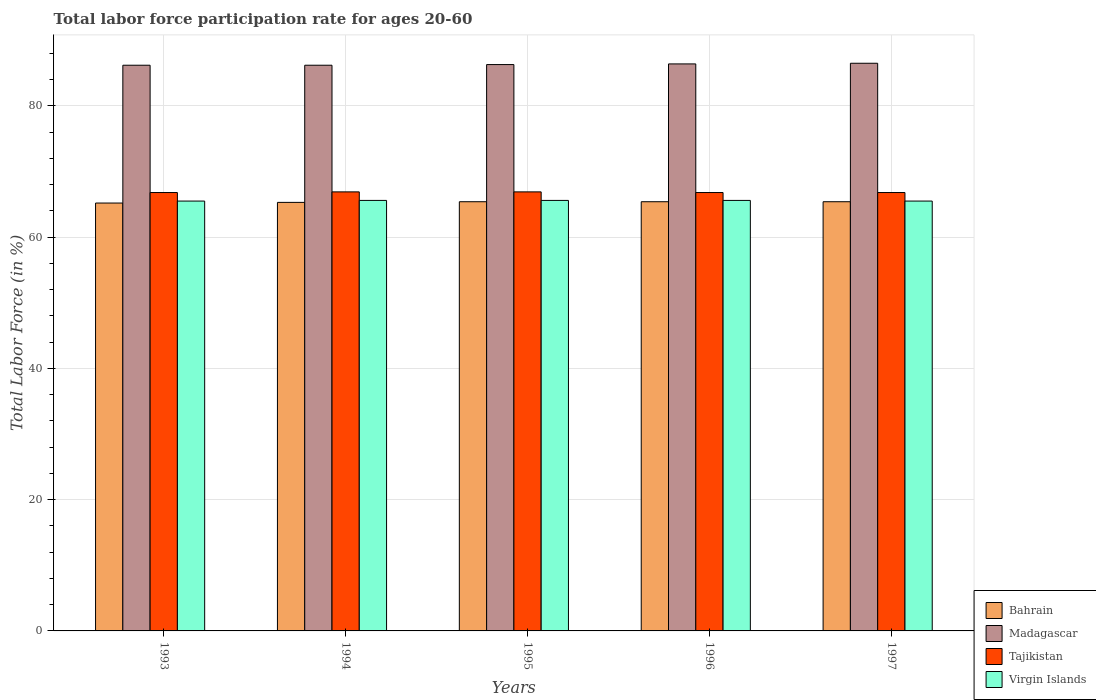Are the number of bars per tick equal to the number of legend labels?
Ensure brevity in your answer.  Yes. Are the number of bars on each tick of the X-axis equal?
Ensure brevity in your answer.  Yes. What is the label of the 3rd group of bars from the left?
Your answer should be very brief. 1995. In how many cases, is the number of bars for a given year not equal to the number of legend labels?
Your response must be concise. 0. What is the labor force participation rate in Virgin Islands in 1995?
Give a very brief answer. 65.6. Across all years, what is the maximum labor force participation rate in Tajikistan?
Your answer should be very brief. 66.9. Across all years, what is the minimum labor force participation rate in Tajikistan?
Offer a terse response. 66.8. In which year was the labor force participation rate in Bahrain maximum?
Your answer should be very brief. 1995. What is the total labor force participation rate in Bahrain in the graph?
Your answer should be very brief. 326.7. What is the difference between the labor force participation rate in Tajikistan in 1996 and that in 1997?
Your response must be concise. 0. What is the difference between the labor force participation rate in Virgin Islands in 1997 and the labor force participation rate in Madagascar in 1995?
Keep it short and to the point. -20.8. What is the average labor force participation rate in Tajikistan per year?
Provide a succinct answer. 66.84. In the year 1993, what is the difference between the labor force participation rate in Tajikistan and labor force participation rate in Virgin Islands?
Offer a very short reply. 1.3. What is the ratio of the labor force participation rate in Madagascar in 1994 to that in 1997?
Provide a succinct answer. 1. Is the labor force participation rate in Tajikistan in 1993 less than that in 1994?
Keep it short and to the point. Yes. Is the difference between the labor force participation rate in Tajikistan in 1995 and 1996 greater than the difference between the labor force participation rate in Virgin Islands in 1995 and 1996?
Ensure brevity in your answer.  Yes. What is the difference between the highest and the second highest labor force participation rate in Virgin Islands?
Ensure brevity in your answer.  0. What is the difference between the highest and the lowest labor force participation rate in Virgin Islands?
Provide a short and direct response. 0.1. In how many years, is the labor force participation rate in Virgin Islands greater than the average labor force participation rate in Virgin Islands taken over all years?
Your answer should be very brief. 3. Is the sum of the labor force participation rate in Madagascar in 1994 and 1995 greater than the maximum labor force participation rate in Bahrain across all years?
Your answer should be very brief. Yes. Is it the case that in every year, the sum of the labor force participation rate in Madagascar and labor force participation rate in Tajikistan is greater than the sum of labor force participation rate in Virgin Islands and labor force participation rate in Bahrain?
Give a very brief answer. Yes. What does the 2nd bar from the left in 1995 represents?
Ensure brevity in your answer.  Madagascar. What does the 3rd bar from the right in 1994 represents?
Give a very brief answer. Madagascar. Are all the bars in the graph horizontal?
Offer a very short reply. No. What is the difference between two consecutive major ticks on the Y-axis?
Your response must be concise. 20. Are the values on the major ticks of Y-axis written in scientific E-notation?
Offer a terse response. No. Does the graph contain grids?
Your response must be concise. Yes. How many legend labels are there?
Offer a terse response. 4. What is the title of the graph?
Provide a short and direct response. Total labor force participation rate for ages 20-60. What is the Total Labor Force (in %) in Bahrain in 1993?
Make the answer very short. 65.2. What is the Total Labor Force (in %) of Madagascar in 1993?
Offer a terse response. 86.2. What is the Total Labor Force (in %) of Tajikistan in 1993?
Offer a terse response. 66.8. What is the Total Labor Force (in %) of Virgin Islands in 1993?
Provide a succinct answer. 65.5. What is the Total Labor Force (in %) in Bahrain in 1994?
Your answer should be very brief. 65.3. What is the Total Labor Force (in %) in Madagascar in 1994?
Offer a very short reply. 86.2. What is the Total Labor Force (in %) in Tajikistan in 1994?
Give a very brief answer. 66.9. What is the Total Labor Force (in %) in Virgin Islands in 1994?
Your response must be concise. 65.6. What is the Total Labor Force (in %) in Bahrain in 1995?
Give a very brief answer. 65.4. What is the Total Labor Force (in %) of Madagascar in 1995?
Give a very brief answer. 86.3. What is the Total Labor Force (in %) in Tajikistan in 1995?
Ensure brevity in your answer.  66.9. What is the Total Labor Force (in %) of Virgin Islands in 1995?
Your response must be concise. 65.6. What is the Total Labor Force (in %) in Bahrain in 1996?
Provide a short and direct response. 65.4. What is the Total Labor Force (in %) in Madagascar in 1996?
Keep it short and to the point. 86.4. What is the Total Labor Force (in %) in Tajikistan in 1996?
Keep it short and to the point. 66.8. What is the Total Labor Force (in %) of Virgin Islands in 1996?
Make the answer very short. 65.6. What is the Total Labor Force (in %) in Bahrain in 1997?
Offer a terse response. 65.4. What is the Total Labor Force (in %) in Madagascar in 1997?
Make the answer very short. 86.5. What is the Total Labor Force (in %) of Tajikistan in 1997?
Provide a succinct answer. 66.8. What is the Total Labor Force (in %) in Virgin Islands in 1997?
Your answer should be compact. 65.5. Across all years, what is the maximum Total Labor Force (in %) of Bahrain?
Offer a very short reply. 65.4. Across all years, what is the maximum Total Labor Force (in %) in Madagascar?
Provide a short and direct response. 86.5. Across all years, what is the maximum Total Labor Force (in %) of Tajikistan?
Provide a succinct answer. 66.9. Across all years, what is the maximum Total Labor Force (in %) in Virgin Islands?
Provide a short and direct response. 65.6. Across all years, what is the minimum Total Labor Force (in %) in Bahrain?
Provide a short and direct response. 65.2. Across all years, what is the minimum Total Labor Force (in %) in Madagascar?
Your answer should be very brief. 86.2. Across all years, what is the minimum Total Labor Force (in %) in Tajikistan?
Keep it short and to the point. 66.8. Across all years, what is the minimum Total Labor Force (in %) in Virgin Islands?
Provide a succinct answer. 65.5. What is the total Total Labor Force (in %) of Bahrain in the graph?
Offer a terse response. 326.7. What is the total Total Labor Force (in %) of Madagascar in the graph?
Offer a very short reply. 431.6. What is the total Total Labor Force (in %) of Tajikistan in the graph?
Make the answer very short. 334.2. What is the total Total Labor Force (in %) of Virgin Islands in the graph?
Your response must be concise. 327.8. What is the difference between the Total Labor Force (in %) in Bahrain in 1993 and that in 1994?
Provide a short and direct response. -0.1. What is the difference between the Total Labor Force (in %) of Madagascar in 1993 and that in 1994?
Offer a terse response. 0. What is the difference between the Total Labor Force (in %) of Tajikistan in 1993 and that in 1994?
Your response must be concise. -0.1. What is the difference between the Total Labor Force (in %) in Bahrain in 1993 and that in 1995?
Your answer should be compact. -0.2. What is the difference between the Total Labor Force (in %) in Tajikistan in 1993 and that in 1995?
Ensure brevity in your answer.  -0.1. What is the difference between the Total Labor Force (in %) in Virgin Islands in 1993 and that in 1995?
Provide a succinct answer. -0.1. What is the difference between the Total Labor Force (in %) of Bahrain in 1993 and that in 1996?
Give a very brief answer. -0.2. What is the difference between the Total Labor Force (in %) of Virgin Islands in 1993 and that in 1996?
Give a very brief answer. -0.1. What is the difference between the Total Labor Force (in %) in Bahrain in 1993 and that in 1997?
Make the answer very short. -0.2. What is the difference between the Total Labor Force (in %) of Madagascar in 1993 and that in 1997?
Ensure brevity in your answer.  -0.3. What is the difference between the Total Labor Force (in %) in Tajikistan in 1993 and that in 1997?
Keep it short and to the point. 0. What is the difference between the Total Labor Force (in %) in Bahrain in 1994 and that in 1995?
Your answer should be very brief. -0.1. What is the difference between the Total Labor Force (in %) in Tajikistan in 1994 and that in 1995?
Provide a short and direct response. 0. What is the difference between the Total Labor Force (in %) of Virgin Islands in 1994 and that in 1995?
Your answer should be compact. 0. What is the difference between the Total Labor Force (in %) of Madagascar in 1994 and that in 1996?
Offer a very short reply. -0.2. What is the difference between the Total Labor Force (in %) of Bahrain in 1994 and that in 1997?
Offer a terse response. -0.1. What is the difference between the Total Labor Force (in %) in Virgin Islands in 1995 and that in 1996?
Make the answer very short. 0. What is the difference between the Total Labor Force (in %) in Madagascar in 1995 and that in 1997?
Make the answer very short. -0.2. What is the difference between the Total Labor Force (in %) in Tajikistan in 1995 and that in 1997?
Give a very brief answer. 0.1. What is the difference between the Total Labor Force (in %) in Virgin Islands in 1995 and that in 1997?
Your response must be concise. 0.1. What is the difference between the Total Labor Force (in %) of Tajikistan in 1996 and that in 1997?
Your answer should be compact. 0. What is the difference between the Total Labor Force (in %) of Madagascar in 1993 and the Total Labor Force (in %) of Tajikistan in 1994?
Offer a very short reply. 19.3. What is the difference between the Total Labor Force (in %) in Madagascar in 1993 and the Total Labor Force (in %) in Virgin Islands in 1994?
Keep it short and to the point. 20.6. What is the difference between the Total Labor Force (in %) in Bahrain in 1993 and the Total Labor Force (in %) in Madagascar in 1995?
Give a very brief answer. -21.1. What is the difference between the Total Labor Force (in %) in Bahrain in 1993 and the Total Labor Force (in %) in Tajikistan in 1995?
Provide a succinct answer. -1.7. What is the difference between the Total Labor Force (in %) in Bahrain in 1993 and the Total Labor Force (in %) in Virgin Islands in 1995?
Offer a very short reply. -0.4. What is the difference between the Total Labor Force (in %) in Madagascar in 1993 and the Total Labor Force (in %) in Tajikistan in 1995?
Keep it short and to the point. 19.3. What is the difference between the Total Labor Force (in %) of Madagascar in 1993 and the Total Labor Force (in %) of Virgin Islands in 1995?
Offer a very short reply. 20.6. What is the difference between the Total Labor Force (in %) in Tajikistan in 1993 and the Total Labor Force (in %) in Virgin Islands in 1995?
Your answer should be very brief. 1.2. What is the difference between the Total Labor Force (in %) of Bahrain in 1993 and the Total Labor Force (in %) of Madagascar in 1996?
Give a very brief answer. -21.2. What is the difference between the Total Labor Force (in %) of Madagascar in 1993 and the Total Labor Force (in %) of Tajikistan in 1996?
Make the answer very short. 19.4. What is the difference between the Total Labor Force (in %) in Madagascar in 1993 and the Total Labor Force (in %) in Virgin Islands in 1996?
Provide a short and direct response. 20.6. What is the difference between the Total Labor Force (in %) in Bahrain in 1993 and the Total Labor Force (in %) in Madagascar in 1997?
Your response must be concise. -21.3. What is the difference between the Total Labor Force (in %) of Madagascar in 1993 and the Total Labor Force (in %) of Tajikistan in 1997?
Offer a terse response. 19.4. What is the difference between the Total Labor Force (in %) of Madagascar in 1993 and the Total Labor Force (in %) of Virgin Islands in 1997?
Provide a short and direct response. 20.7. What is the difference between the Total Labor Force (in %) in Bahrain in 1994 and the Total Labor Force (in %) in Virgin Islands in 1995?
Provide a succinct answer. -0.3. What is the difference between the Total Labor Force (in %) of Madagascar in 1994 and the Total Labor Force (in %) of Tajikistan in 1995?
Keep it short and to the point. 19.3. What is the difference between the Total Labor Force (in %) of Madagascar in 1994 and the Total Labor Force (in %) of Virgin Islands in 1995?
Give a very brief answer. 20.6. What is the difference between the Total Labor Force (in %) of Bahrain in 1994 and the Total Labor Force (in %) of Madagascar in 1996?
Ensure brevity in your answer.  -21.1. What is the difference between the Total Labor Force (in %) in Bahrain in 1994 and the Total Labor Force (in %) in Virgin Islands in 1996?
Offer a very short reply. -0.3. What is the difference between the Total Labor Force (in %) of Madagascar in 1994 and the Total Labor Force (in %) of Virgin Islands in 1996?
Your answer should be compact. 20.6. What is the difference between the Total Labor Force (in %) in Bahrain in 1994 and the Total Labor Force (in %) in Madagascar in 1997?
Make the answer very short. -21.2. What is the difference between the Total Labor Force (in %) in Bahrain in 1994 and the Total Labor Force (in %) in Virgin Islands in 1997?
Make the answer very short. -0.2. What is the difference between the Total Labor Force (in %) of Madagascar in 1994 and the Total Labor Force (in %) of Virgin Islands in 1997?
Provide a succinct answer. 20.7. What is the difference between the Total Labor Force (in %) in Bahrain in 1995 and the Total Labor Force (in %) in Madagascar in 1996?
Provide a short and direct response. -21. What is the difference between the Total Labor Force (in %) in Bahrain in 1995 and the Total Labor Force (in %) in Tajikistan in 1996?
Give a very brief answer. -1.4. What is the difference between the Total Labor Force (in %) of Madagascar in 1995 and the Total Labor Force (in %) of Virgin Islands in 1996?
Offer a very short reply. 20.7. What is the difference between the Total Labor Force (in %) in Bahrain in 1995 and the Total Labor Force (in %) in Madagascar in 1997?
Your response must be concise. -21.1. What is the difference between the Total Labor Force (in %) of Bahrain in 1995 and the Total Labor Force (in %) of Virgin Islands in 1997?
Keep it short and to the point. -0.1. What is the difference between the Total Labor Force (in %) of Madagascar in 1995 and the Total Labor Force (in %) of Virgin Islands in 1997?
Offer a terse response. 20.8. What is the difference between the Total Labor Force (in %) of Bahrain in 1996 and the Total Labor Force (in %) of Madagascar in 1997?
Ensure brevity in your answer.  -21.1. What is the difference between the Total Labor Force (in %) of Madagascar in 1996 and the Total Labor Force (in %) of Tajikistan in 1997?
Make the answer very short. 19.6. What is the difference between the Total Labor Force (in %) in Madagascar in 1996 and the Total Labor Force (in %) in Virgin Islands in 1997?
Give a very brief answer. 20.9. What is the average Total Labor Force (in %) of Bahrain per year?
Your response must be concise. 65.34. What is the average Total Labor Force (in %) of Madagascar per year?
Keep it short and to the point. 86.32. What is the average Total Labor Force (in %) in Tajikistan per year?
Ensure brevity in your answer.  66.84. What is the average Total Labor Force (in %) in Virgin Islands per year?
Make the answer very short. 65.56. In the year 1993, what is the difference between the Total Labor Force (in %) of Bahrain and Total Labor Force (in %) of Virgin Islands?
Offer a terse response. -0.3. In the year 1993, what is the difference between the Total Labor Force (in %) in Madagascar and Total Labor Force (in %) in Virgin Islands?
Your response must be concise. 20.7. In the year 1993, what is the difference between the Total Labor Force (in %) of Tajikistan and Total Labor Force (in %) of Virgin Islands?
Your answer should be very brief. 1.3. In the year 1994, what is the difference between the Total Labor Force (in %) of Bahrain and Total Labor Force (in %) of Madagascar?
Offer a very short reply. -20.9. In the year 1994, what is the difference between the Total Labor Force (in %) of Bahrain and Total Labor Force (in %) of Virgin Islands?
Offer a terse response. -0.3. In the year 1994, what is the difference between the Total Labor Force (in %) in Madagascar and Total Labor Force (in %) in Tajikistan?
Give a very brief answer. 19.3. In the year 1994, what is the difference between the Total Labor Force (in %) of Madagascar and Total Labor Force (in %) of Virgin Islands?
Give a very brief answer. 20.6. In the year 1994, what is the difference between the Total Labor Force (in %) of Tajikistan and Total Labor Force (in %) of Virgin Islands?
Your answer should be compact. 1.3. In the year 1995, what is the difference between the Total Labor Force (in %) in Bahrain and Total Labor Force (in %) in Madagascar?
Provide a succinct answer. -20.9. In the year 1995, what is the difference between the Total Labor Force (in %) of Bahrain and Total Labor Force (in %) of Virgin Islands?
Offer a very short reply. -0.2. In the year 1995, what is the difference between the Total Labor Force (in %) of Madagascar and Total Labor Force (in %) of Tajikistan?
Offer a very short reply. 19.4. In the year 1995, what is the difference between the Total Labor Force (in %) in Madagascar and Total Labor Force (in %) in Virgin Islands?
Offer a very short reply. 20.7. In the year 1996, what is the difference between the Total Labor Force (in %) of Bahrain and Total Labor Force (in %) of Virgin Islands?
Offer a terse response. -0.2. In the year 1996, what is the difference between the Total Labor Force (in %) of Madagascar and Total Labor Force (in %) of Tajikistan?
Your response must be concise. 19.6. In the year 1996, what is the difference between the Total Labor Force (in %) in Madagascar and Total Labor Force (in %) in Virgin Islands?
Your response must be concise. 20.8. In the year 1997, what is the difference between the Total Labor Force (in %) of Bahrain and Total Labor Force (in %) of Madagascar?
Offer a very short reply. -21.1. In the year 1997, what is the difference between the Total Labor Force (in %) in Bahrain and Total Labor Force (in %) in Tajikistan?
Provide a succinct answer. -1.4. In the year 1997, what is the difference between the Total Labor Force (in %) of Bahrain and Total Labor Force (in %) of Virgin Islands?
Make the answer very short. -0.1. In the year 1997, what is the difference between the Total Labor Force (in %) in Madagascar and Total Labor Force (in %) in Tajikistan?
Give a very brief answer. 19.7. In the year 1997, what is the difference between the Total Labor Force (in %) of Tajikistan and Total Labor Force (in %) of Virgin Islands?
Offer a terse response. 1.3. What is the ratio of the Total Labor Force (in %) of Tajikistan in 1993 to that in 1994?
Provide a succinct answer. 1. What is the ratio of the Total Labor Force (in %) of Virgin Islands in 1993 to that in 1994?
Provide a succinct answer. 1. What is the ratio of the Total Labor Force (in %) of Bahrain in 1993 to that in 1995?
Provide a succinct answer. 1. What is the ratio of the Total Labor Force (in %) in Tajikistan in 1993 to that in 1995?
Provide a succinct answer. 1. What is the ratio of the Total Labor Force (in %) of Virgin Islands in 1993 to that in 1995?
Keep it short and to the point. 1. What is the ratio of the Total Labor Force (in %) of Madagascar in 1993 to that in 1996?
Offer a terse response. 1. What is the ratio of the Total Labor Force (in %) in Virgin Islands in 1993 to that in 1996?
Your answer should be very brief. 1. What is the ratio of the Total Labor Force (in %) of Madagascar in 1993 to that in 1997?
Your response must be concise. 1. What is the ratio of the Total Labor Force (in %) of Tajikistan in 1993 to that in 1997?
Give a very brief answer. 1. What is the ratio of the Total Labor Force (in %) of Virgin Islands in 1993 to that in 1997?
Provide a succinct answer. 1. What is the ratio of the Total Labor Force (in %) of Madagascar in 1994 to that in 1995?
Make the answer very short. 1. What is the ratio of the Total Labor Force (in %) in Madagascar in 1994 to that in 1996?
Keep it short and to the point. 1. What is the ratio of the Total Labor Force (in %) of Tajikistan in 1994 to that in 1996?
Your answer should be very brief. 1. What is the ratio of the Total Labor Force (in %) in Virgin Islands in 1994 to that in 1996?
Offer a terse response. 1. What is the ratio of the Total Labor Force (in %) of Bahrain in 1994 to that in 1997?
Make the answer very short. 1. What is the ratio of the Total Labor Force (in %) in Madagascar in 1994 to that in 1997?
Your response must be concise. 1. What is the ratio of the Total Labor Force (in %) in Tajikistan in 1994 to that in 1997?
Keep it short and to the point. 1. What is the ratio of the Total Labor Force (in %) in Virgin Islands in 1994 to that in 1997?
Keep it short and to the point. 1. What is the ratio of the Total Labor Force (in %) in Madagascar in 1995 to that in 1996?
Keep it short and to the point. 1. What is the ratio of the Total Labor Force (in %) of Tajikistan in 1995 to that in 1996?
Make the answer very short. 1. What is the ratio of the Total Labor Force (in %) in Madagascar in 1995 to that in 1997?
Offer a terse response. 1. What is the ratio of the Total Labor Force (in %) in Madagascar in 1996 to that in 1997?
Offer a terse response. 1. What is the ratio of the Total Labor Force (in %) of Virgin Islands in 1996 to that in 1997?
Give a very brief answer. 1. What is the difference between the highest and the second highest Total Labor Force (in %) of Bahrain?
Ensure brevity in your answer.  0. What is the difference between the highest and the second highest Total Labor Force (in %) in Madagascar?
Keep it short and to the point. 0.1. What is the difference between the highest and the second highest Total Labor Force (in %) in Tajikistan?
Provide a short and direct response. 0. What is the difference between the highest and the second highest Total Labor Force (in %) of Virgin Islands?
Give a very brief answer. 0. What is the difference between the highest and the lowest Total Labor Force (in %) in Tajikistan?
Your answer should be very brief. 0.1. 